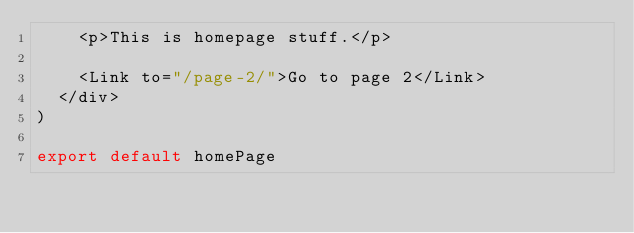<code> <loc_0><loc_0><loc_500><loc_500><_JavaScript_>    <p>This is homepage stuff.</p>
    
    <Link to="/page-2/">Go to page 2</Link>
  </div>
)

export default homePage</code> 